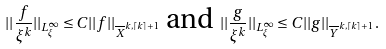<formula> <loc_0><loc_0><loc_500><loc_500>| | \frac { f } { \xi ^ { k } } | | _ { L _ { \xi } ^ { \infty } } \leq C | | f | | _ { \overline { X } ^ { k , \lceil k \rceil + 1 } } \text { and } | | \frac { g } { \xi ^ { k } } | | _ { L _ { \xi } ^ { \infty } } \leq C | | g | | _ { \overline { Y } ^ { k , \lceil k \rceil + 1 } } \, .</formula> 